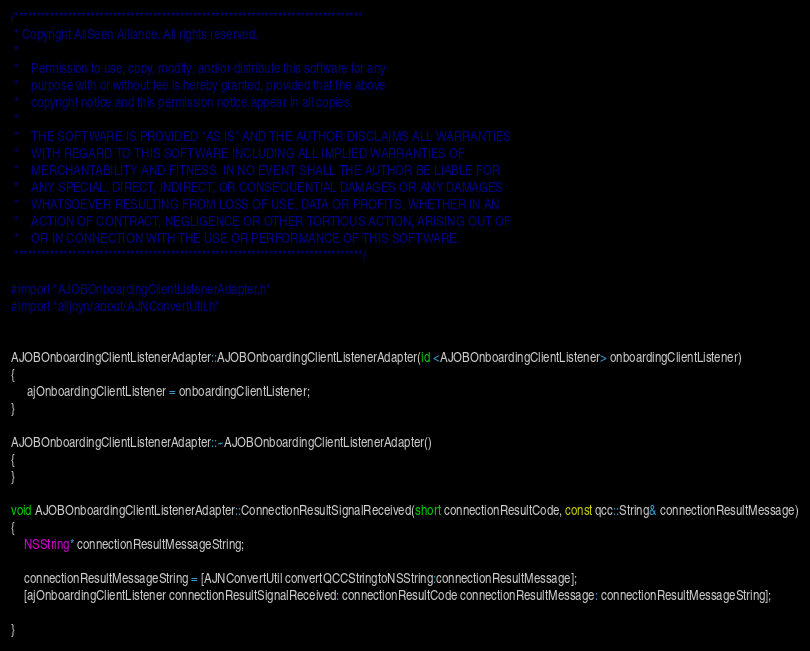Convert code to text. <code><loc_0><loc_0><loc_500><loc_500><_ObjectiveC_>/******************************************************************************
 * Copyright AllSeen Alliance. All rights reserved.
 *
 *    Permission to use, copy, modify, and/or distribute this software for any
 *    purpose with or without fee is hereby granted, provided that the above
 *    copyright notice and this permission notice appear in all copies.
 *
 *    THE SOFTWARE IS PROVIDED "AS IS" AND THE AUTHOR DISCLAIMS ALL WARRANTIES
 *    WITH REGARD TO THIS SOFTWARE INCLUDING ALL IMPLIED WARRANTIES OF
 *    MERCHANTABILITY AND FITNESS. IN NO EVENT SHALL THE AUTHOR BE LIABLE FOR
 *    ANY SPECIAL, DIRECT, INDIRECT, OR CONSEQUENTIAL DAMAGES OR ANY DAMAGES
 *    WHATSOEVER RESULTING FROM LOSS OF USE, DATA OR PROFITS, WHETHER IN AN
 *    ACTION OF CONTRACT, NEGLIGENCE OR OTHER TORTIOUS ACTION, ARISING OUT OF
 *    OR IN CONNECTION WITH THE USE OR PERFORMANCE OF THIS SOFTWARE.
 ******************************************************************************/

#import "AJOBOnboardingClientListenerAdapter.h"
#import "alljoyn/about/AJNConvertUtil.h"


AJOBOnboardingClientListenerAdapter::AJOBOnboardingClientListenerAdapter(id <AJOBOnboardingClientListener> onboardingClientListener)
{
	 ajOnboardingClientListener = onboardingClientListener;
}

AJOBOnboardingClientListenerAdapter::~AJOBOnboardingClientListenerAdapter()
{
}

void AJOBOnboardingClientListenerAdapter::ConnectionResultSignalReceived(short connectionResultCode, const qcc::String& connectionResultMessage)
{
    NSString* connectionResultMessageString;
    
    connectionResultMessageString = [AJNConvertUtil convertQCCStringtoNSString:connectionResultMessage];
    [ajOnboardingClientListener connectionResultSignalReceived: connectionResultCode connectionResultMessage: connectionResultMessageString];
    
}
</code> 